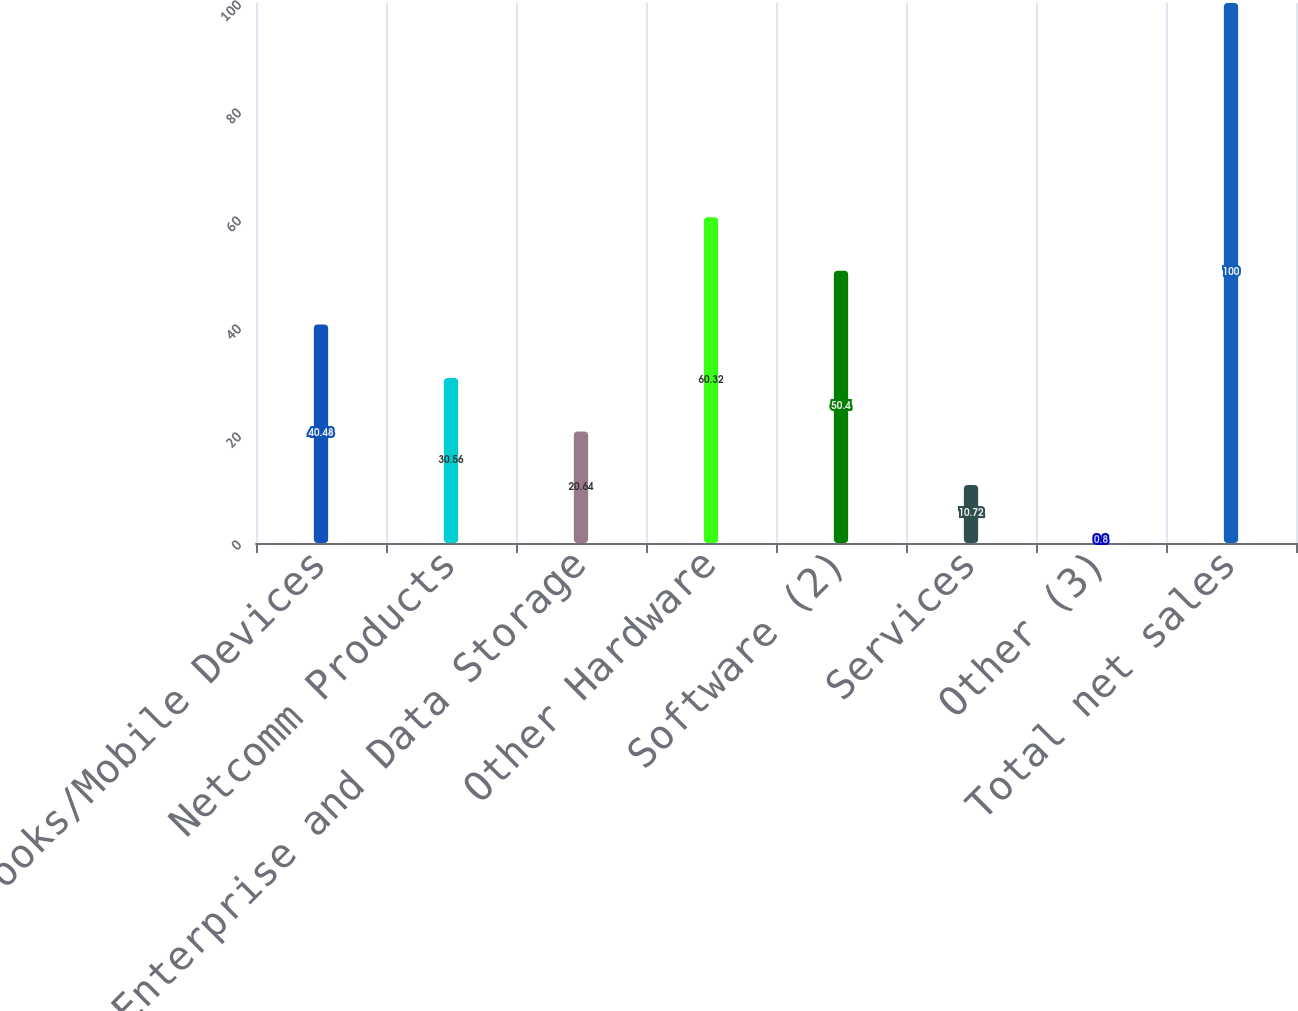Convert chart. <chart><loc_0><loc_0><loc_500><loc_500><bar_chart><fcel>Notebooks/Mobile Devices<fcel>Netcomm Products<fcel>Enterprise and Data Storage<fcel>Other Hardware<fcel>Software (2)<fcel>Services<fcel>Other (3)<fcel>Total net sales<nl><fcel>40.48<fcel>30.56<fcel>20.64<fcel>60.32<fcel>50.4<fcel>10.72<fcel>0.8<fcel>100<nl></chart> 